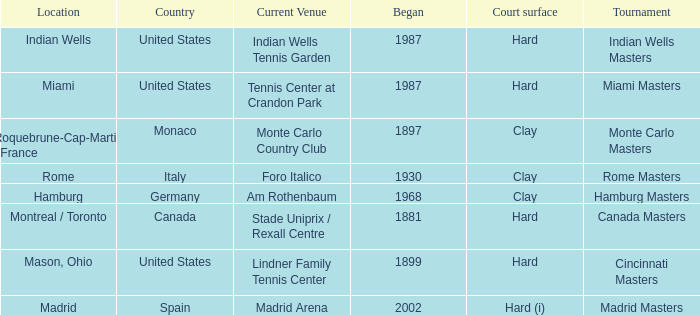Rome is in which country? Italy. 